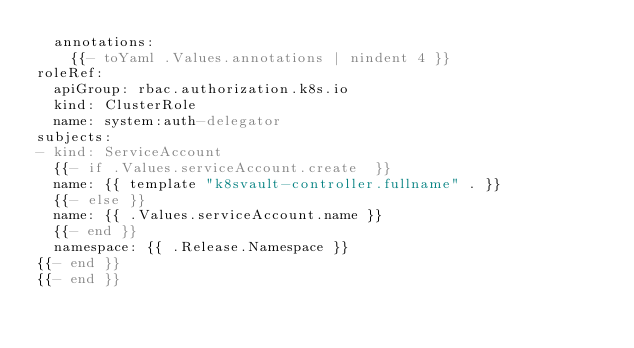<code> <loc_0><loc_0><loc_500><loc_500><_YAML_>  annotations:
    {{- toYaml .Values.annotations | nindent 4 }}
roleRef:
  apiGroup: rbac.authorization.k8s.io
  kind: ClusterRole
  name: system:auth-delegator
subjects:
- kind: ServiceAccount
  {{- if .Values.serviceAccount.create  }}
  name: {{ template "k8svault-controller.fullname" . }}
  {{- else }}
  name: {{ .Values.serviceAccount.name }}
  {{- end }}
  namespace: {{ .Release.Namespace }}
{{- end }}
{{- end }}
</code> 